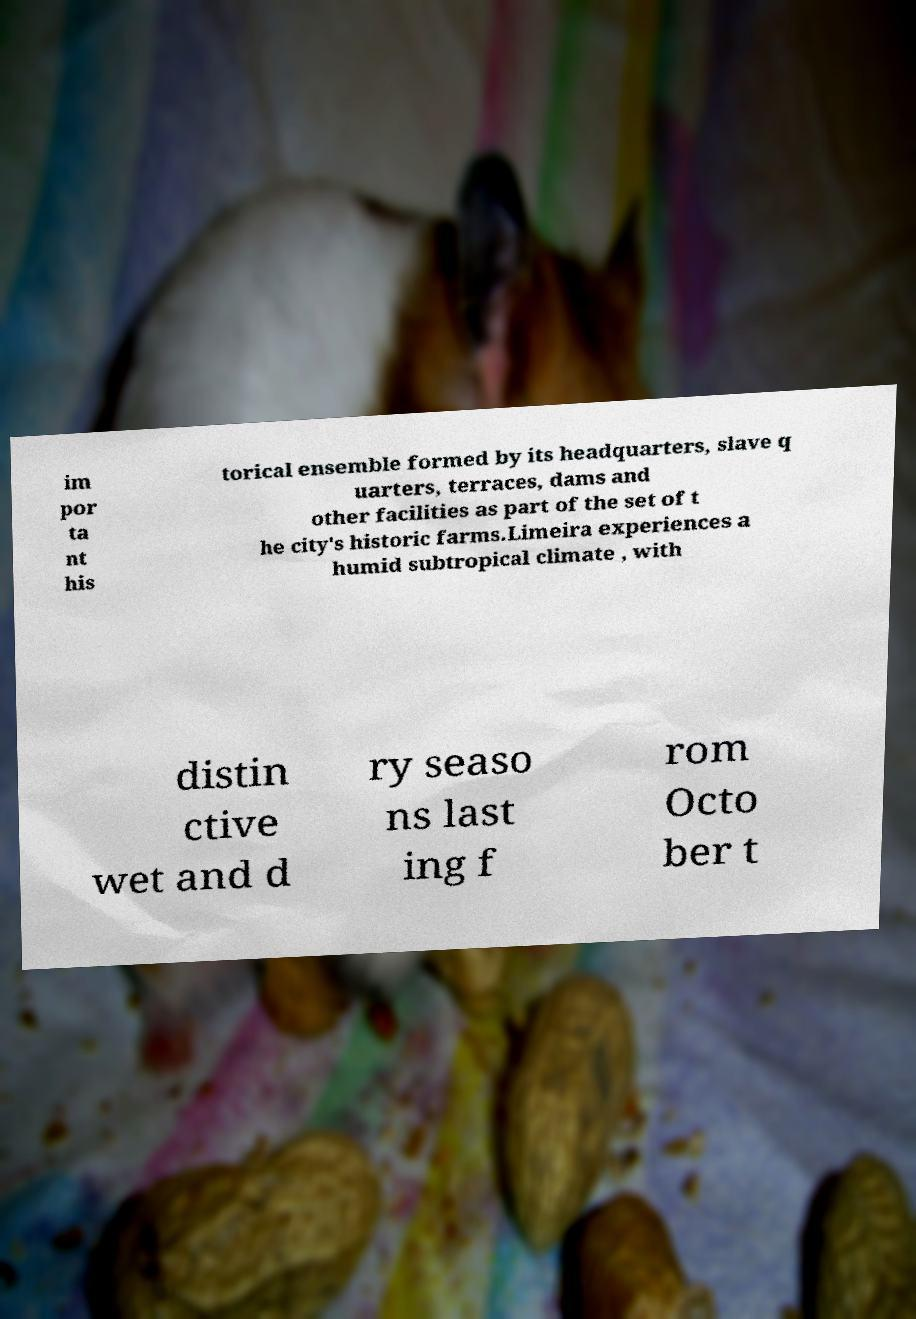There's text embedded in this image that I need extracted. Can you transcribe it verbatim? im por ta nt his torical ensemble formed by its headquarters, slave q uarters, terraces, dams and other facilities as part of the set of t he city's historic farms.Limeira experiences a humid subtropical climate , with distin ctive wet and d ry seaso ns last ing f rom Octo ber t 